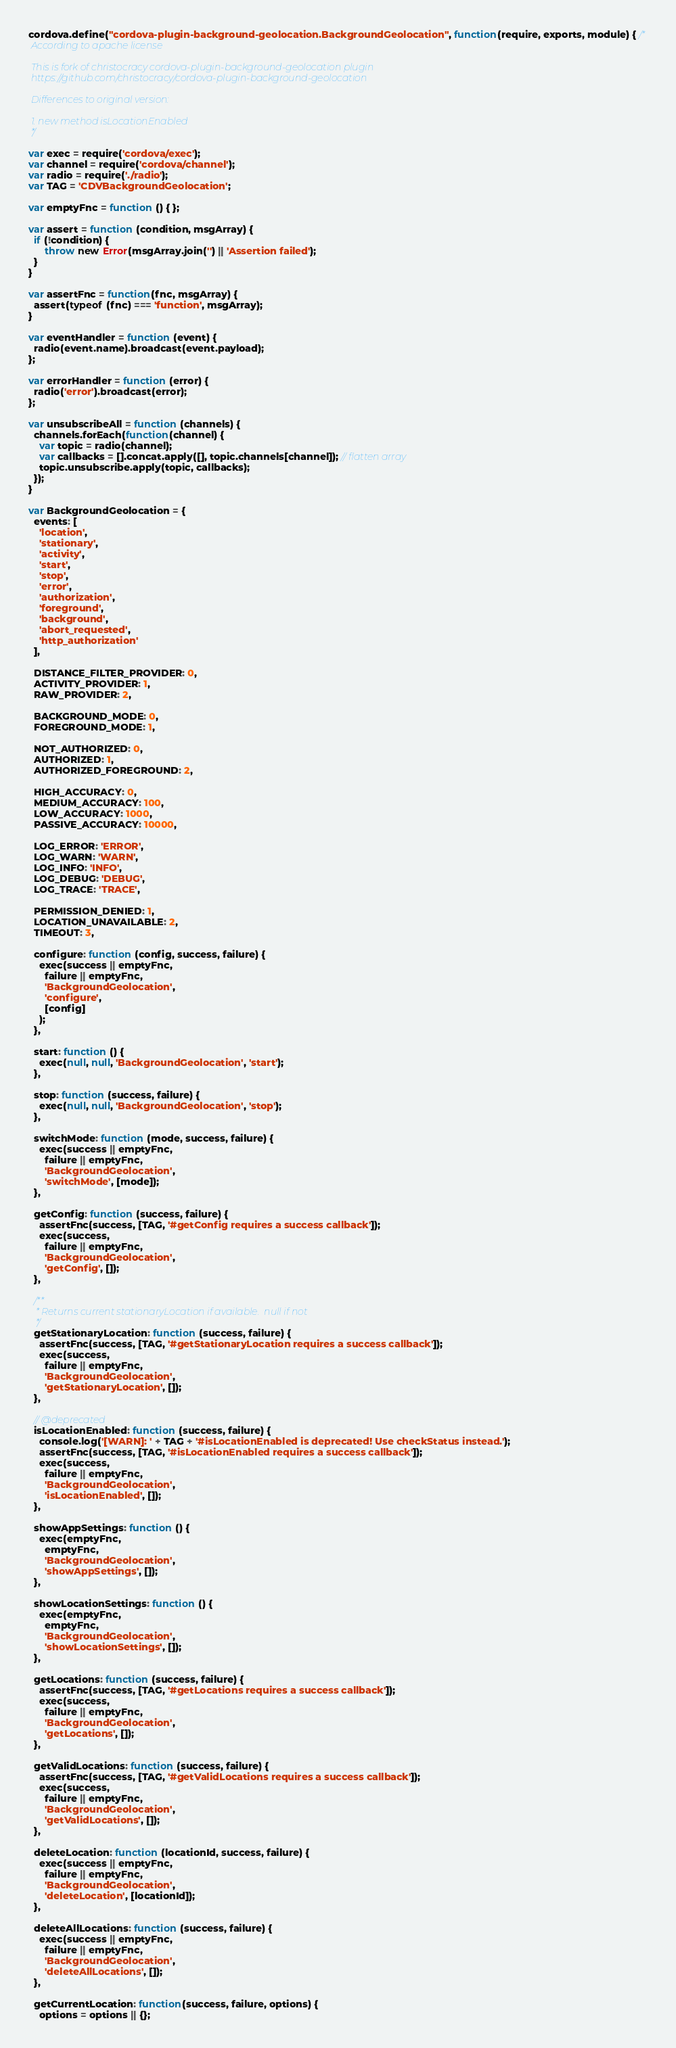<code> <loc_0><loc_0><loc_500><loc_500><_JavaScript_>cordova.define("cordova-plugin-background-geolocation.BackgroundGeolocation", function(require, exports, module) { /*
 According to apache license

 This is fork of christocracy cordova-plugin-background-geolocation plugin
 https://github.com/christocracy/cordova-plugin-background-geolocation

 Differences to original version:

 1. new method isLocationEnabled
 */

var exec = require('cordova/exec');
var channel = require('cordova/channel');
var radio = require('./radio');
var TAG = 'CDVBackgroundGeolocation';

var emptyFnc = function () { };

var assert = function (condition, msgArray) {
  if (!condition) {
      throw new Error(msgArray.join('') || 'Assertion failed');
  }
}

var assertFnc = function(fnc, msgArray) {
  assert(typeof (fnc) === 'function', msgArray);
}

var eventHandler = function (event) {
  radio(event.name).broadcast(event.payload);
};

var errorHandler = function (error) {
  radio('error').broadcast(error);
};

var unsubscribeAll = function (channels) {
  channels.forEach(function(channel) {
    var topic = radio(channel);
    var callbacks = [].concat.apply([], topic.channels[channel]); // flatten array
    topic.unsubscribe.apply(topic, callbacks);
  });
}

var BackgroundGeolocation = {
  events: [
    'location',
    'stationary',
    'activity',
    'start',
    'stop',
    'error',
    'authorization',
    'foreground',
    'background',
    'abort_requested',
    'http_authorization'
  ],

  DISTANCE_FILTER_PROVIDER: 0,
  ACTIVITY_PROVIDER: 1,
  RAW_PROVIDER: 2,

  BACKGROUND_MODE: 0,
  FOREGROUND_MODE: 1,

  NOT_AUTHORIZED: 0,
  AUTHORIZED: 1,
  AUTHORIZED_FOREGROUND: 2,

  HIGH_ACCURACY: 0,
  MEDIUM_ACCURACY: 100,
  LOW_ACCURACY: 1000,
  PASSIVE_ACCURACY: 10000,

  LOG_ERROR: 'ERROR',
  LOG_WARN: 'WARN',
  LOG_INFO: 'INFO',
  LOG_DEBUG: 'DEBUG',
  LOG_TRACE: 'TRACE',

  PERMISSION_DENIED: 1,
  LOCATION_UNAVAILABLE: 2,
  TIMEOUT: 3,

  configure: function (config, success, failure) {
    exec(success || emptyFnc,
      failure || emptyFnc,
      'BackgroundGeolocation',
      'configure',
      [config]
    );
  },

  start: function () {
    exec(null, null, 'BackgroundGeolocation', 'start');
  },

  stop: function (success, failure) {
    exec(null, null, 'BackgroundGeolocation', 'stop');
  },

  switchMode: function (mode, success, failure) {
    exec(success || emptyFnc,
      failure || emptyFnc,
      'BackgroundGeolocation',
      'switchMode', [mode]);
  },

  getConfig: function (success, failure) {
    assertFnc(success, [TAG, '#getConfig requires a success callback']);
    exec(success,
      failure || emptyFnc,
      'BackgroundGeolocation',
      'getConfig', []);
  },

  /**
   * Returns current stationaryLocation if available.  null if not
   */
  getStationaryLocation: function (success, failure) {
    assertFnc(success, [TAG, '#getStationaryLocation requires a success callback']);
    exec(success,
      failure || emptyFnc,
      'BackgroundGeolocation',
      'getStationaryLocation', []);
  },

  // @deprecated
  isLocationEnabled: function (success, failure) {
    console.log('[WARN]: ' + TAG + '#isLocationEnabled is deprecated! Use checkStatus instead.');
    assertFnc(success, [TAG, '#isLocationEnabled requires a success callback']);
    exec(success,
      failure || emptyFnc,
      'BackgroundGeolocation',
      'isLocationEnabled', []);
  },

  showAppSettings: function () {
    exec(emptyFnc,
      emptyFnc,
      'BackgroundGeolocation',
      'showAppSettings', []);
  },

  showLocationSettings: function () {
    exec(emptyFnc,
      emptyFnc,
      'BackgroundGeolocation',
      'showLocationSettings', []);
  },

  getLocations: function (success, failure) {
    assertFnc(success, [TAG, '#getLocations requires a success callback']);
    exec(success,
      failure || emptyFnc,
      'BackgroundGeolocation',
      'getLocations', []);
  },

  getValidLocations: function (success, failure) {
    assertFnc(success, [TAG, '#getValidLocations requires a success callback']);
    exec(success,
      failure || emptyFnc,
      'BackgroundGeolocation',
      'getValidLocations', []);
  },

  deleteLocation: function (locationId, success, failure) {
    exec(success || emptyFnc,
      failure || emptyFnc,
      'BackgroundGeolocation',
      'deleteLocation', [locationId]);
  },

  deleteAllLocations: function (success, failure) {
    exec(success || emptyFnc,
      failure || emptyFnc,
      'BackgroundGeolocation',
      'deleteAllLocations', []);
  },

  getCurrentLocation: function(success, failure, options) {
    options = options || {};</code> 